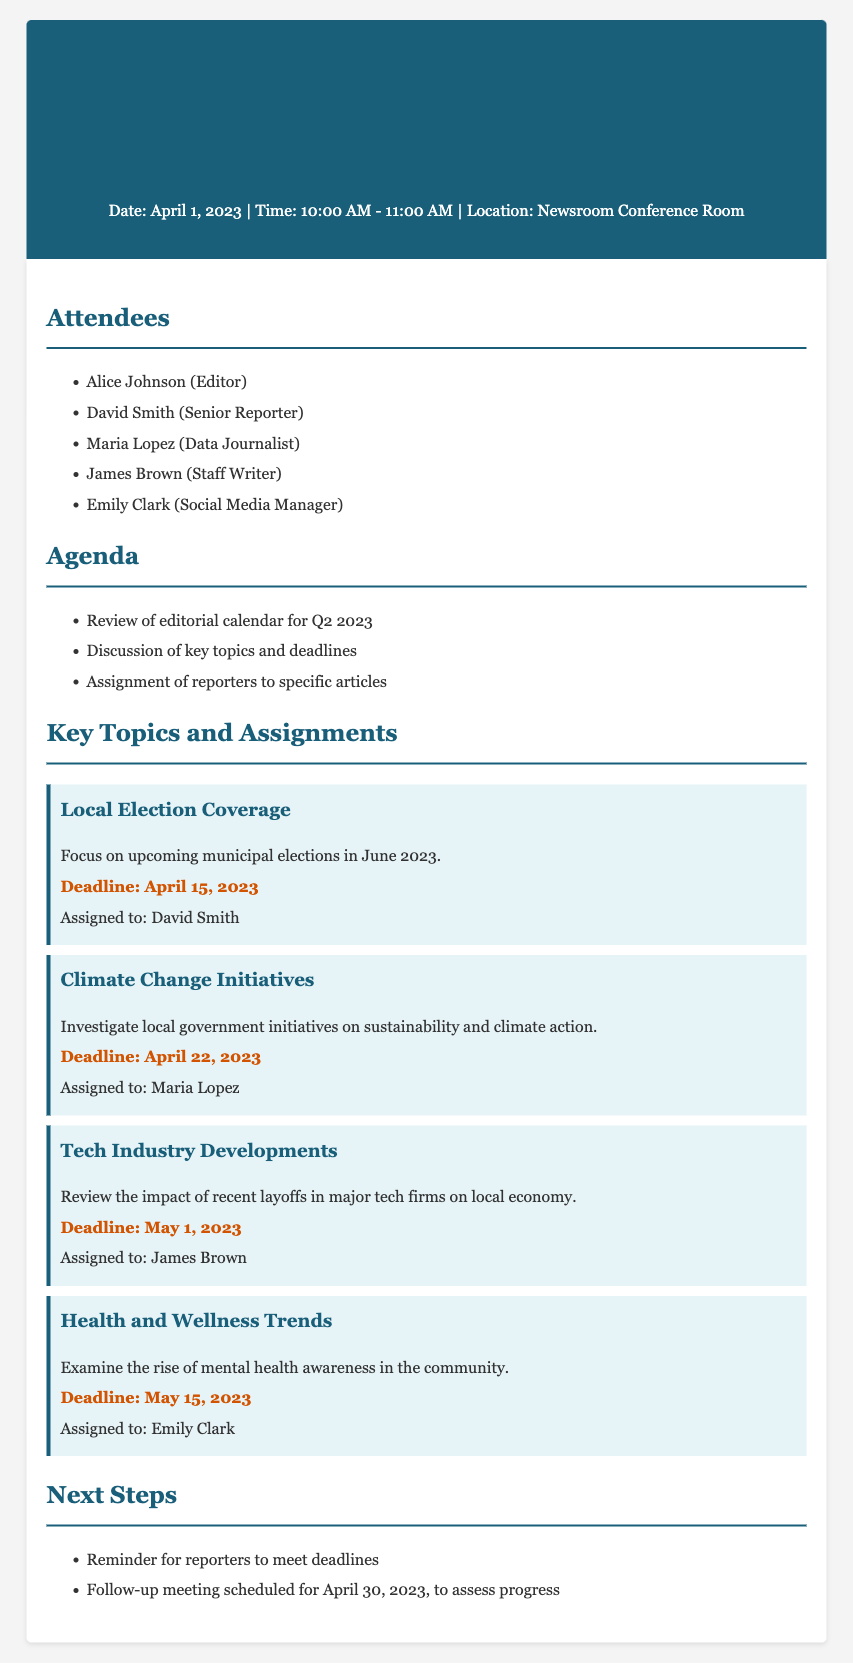What is the date of the meeting? The date of the meeting is mentioned in the header section of the document.
Answer: April 1, 2023 Who is assigned to cover Local Election Coverage? The assignment details for Local Election Coverage are provided in the Key Topics section.
Answer: David Smith What is the deadline for the article on Climate Change Initiatives? The deadline for Climate Change Initiatives can be found in the Key Topics section under that specific topic.
Answer: April 22, 2023 How many attendees were present at the meeting? The number of attendees is listed in the Attendees section of the document.
Answer: Five What topic examines the rise of mental health awareness? The topics listed in the Key Topics section specify this area of focus.
Answer: Health and Wellness Trends What is the date of the follow-up meeting? The follow-up meeting date is mentioned in the Next Steps section of the document.
Answer: April 30, 2023 Which reporter is assigned to Tech Industry Developments? This information is contained in the Key Topics section where assignments are explicitly stated.
Answer: James Brown What is the focus of the article on Health and Wellness Trends? The focus is outlined in the description under the Health and Wellness Trends topic in the Key Topics section.
Answer: Mental health awareness in the community What is the location of the meeting? The location of the meeting is stated in the header section.
Answer: Newsroom Conference Room 